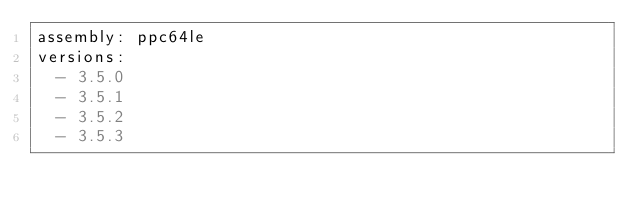<code> <loc_0><loc_0><loc_500><loc_500><_YAML_>assembly: ppc64le
versions:
  - 3.5.0
  - 3.5.1
  - 3.5.2
  - 3.5.3
</code> 